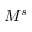Convert formula to latex. <formula><loc_0><loc_0><loc_500><loc_500>M ^ { s }</formula> 